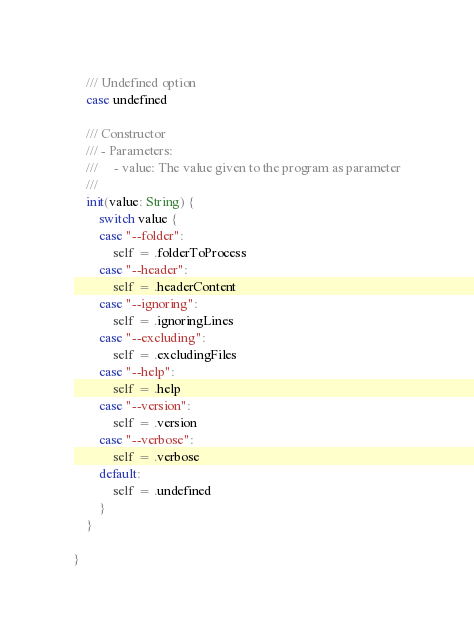Convert code to text. <code><loc_0><loc_0><loc_500><loc_500><_Swift_>
    /// Undefined option
    case undefined

    /// Constructor
    /// - Parameters:
    ///     - value: The value given to the program as parameter
    ///
    init(value: String) {
        switch value {
        case "--folder":
            self = .folderToProcess
        case "--header":
            self = .headerContent
        case "--ignoring":
            self = .ignoringLines
        case "--excluding":
            self = .excludingFiles
        case "--help":
            self = .help
        case "--version":
            self = .version
        case "--verbose":
            self = .verbose
        default:
            self = .undefined
        }
    }

}
</code> 